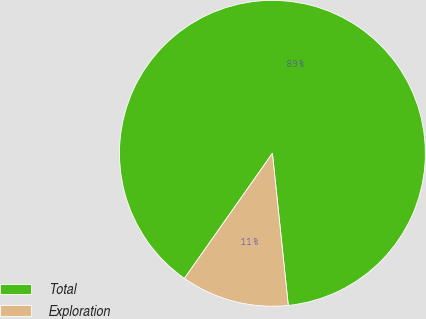Convert chart. <chart><loc_0><loc_0><loc_500><loc_500><pie_chart><fcel>Total<fcel>Exploration<nl><fcel>88.59%<fcel>11.41%<nl></chart> 